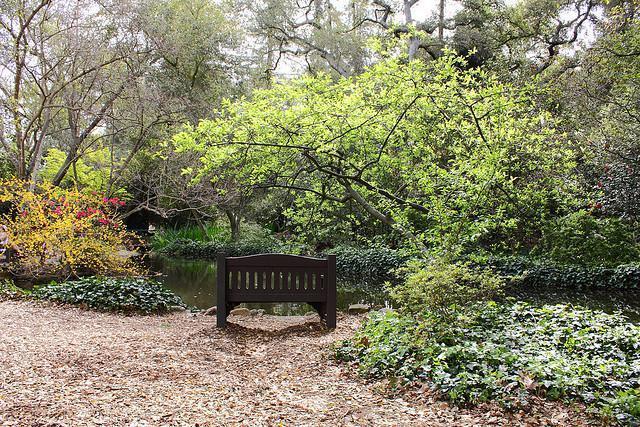How many benches are here?
Give a very brief answer. 1. How many people are wearing pink pants?
Give a very brief answer. 0. 